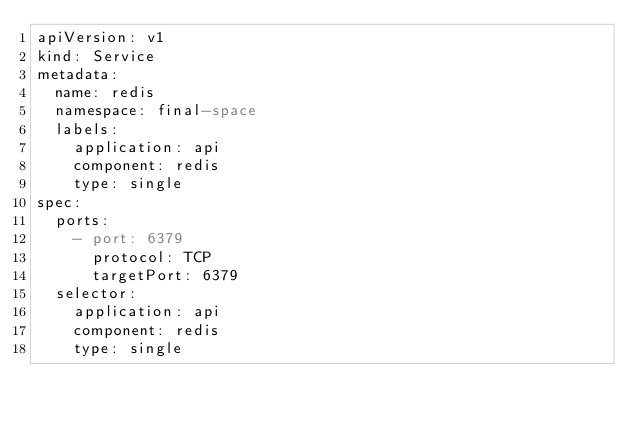<code> <loc_0><loc_0><loc_500><loc_500><_YAML_>apiVersion: v1
kind: Service
metadata:
  name: redis
  namespace: final-space
  labels:
    application: api
    component: redis
    type: single
spec:
  ports:
    - port: 6379
      protocol: TCP
      targetPort: 6379
  selector:
    application: api
    component: redis
    type: single
</code> 